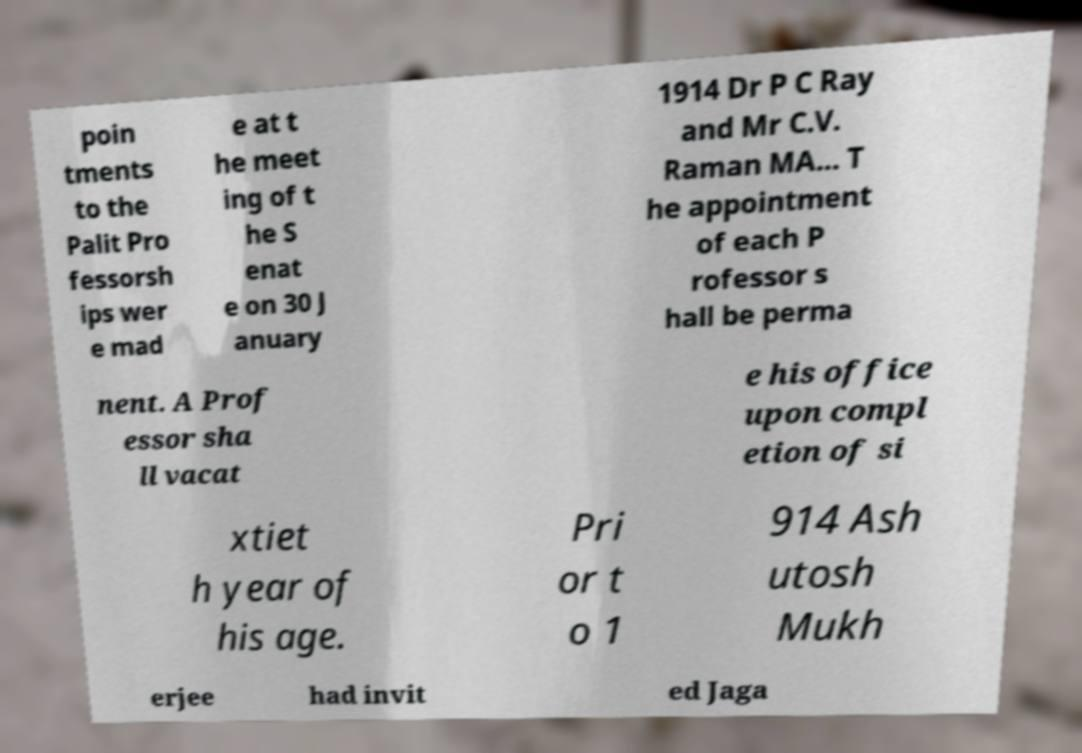Can you accurately transcribe the text from the provided image for me? poin tments to the Palit Pro fessorsh ips wer e mad e at t he meet ing of t he S enat e on 30 J anuary 1914 Dr P C Ray and Mr C.V. Raman MA... T he appointment of each P rofessor s hall be perma nent. A Prof essor sha ll vacat e his office upon compl etion of si xtiet h year of his age. Pri or t o 1 914 Ash utosh Mukh erjee had invit ed Jaga 